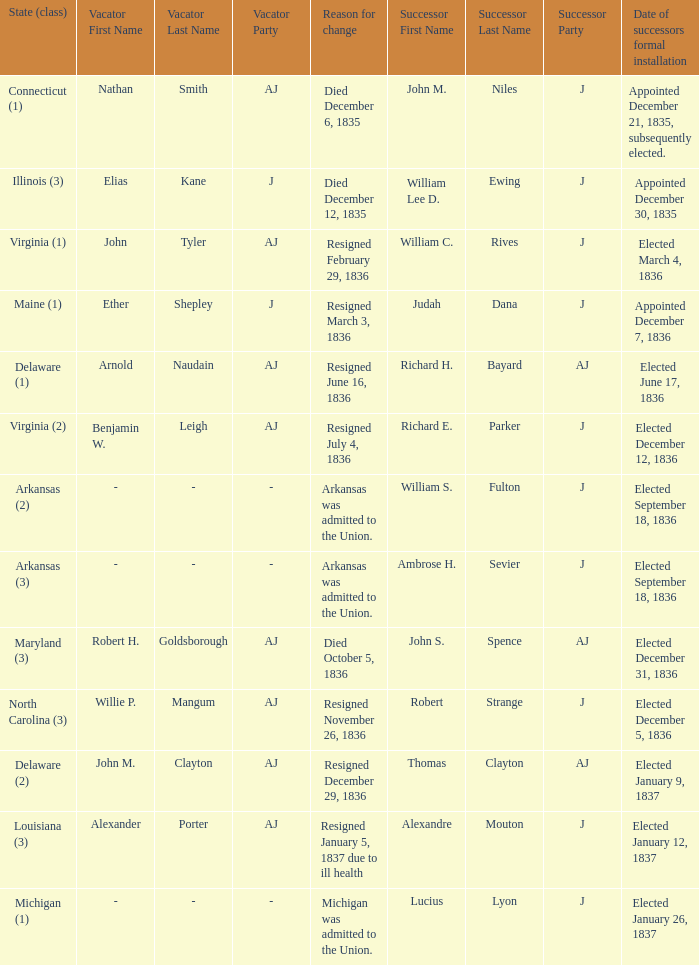Name the successor for elected january 26, 1837 1.0. 